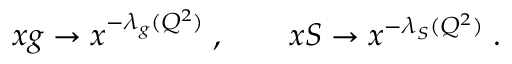Convert formula to latex. <formula><loc_0><loc_0><loc_500><loc_500>x g \to x ^ { - \lambda _ { g } ( Q ^ { 2 } ) } \, , \quad x S \to x ^ { - \lambda _ { S } ( Q ^ { 2 } ) } \, .</formula> 